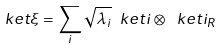Convert formula to latex. <formula><loc_0><loc_0><loc_500><loc_500>\ k e t { \xi } = \sum _ { i } \sqrt { \lambda _ { i } } \ k e t { i } \otimes \ k e t { i _ { R } }</formula> 